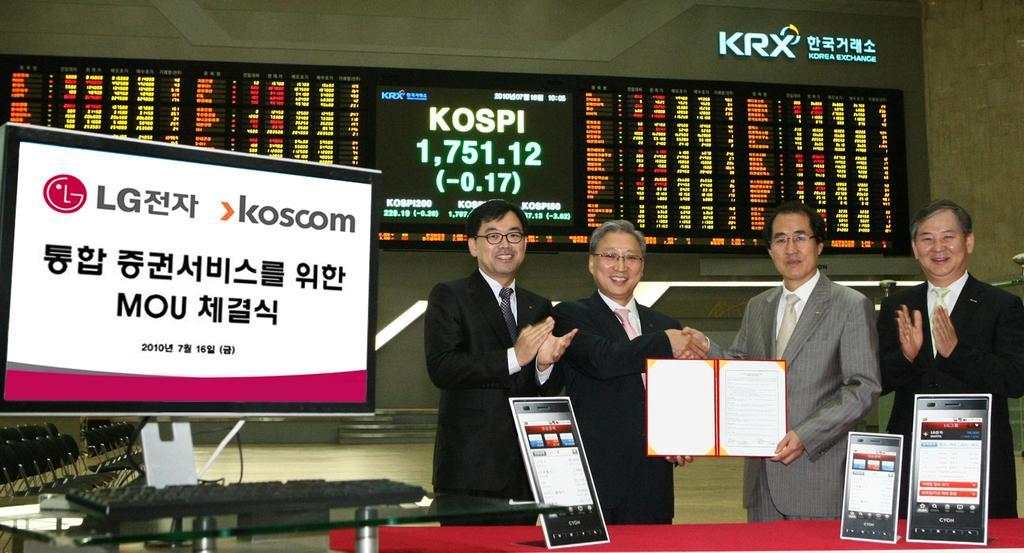Describe this image in one or two sentences. In this image there are persons standing, there is a person holding an object, there is table truncated towards the bottom of the image, there are objects on the table, there is a keyboard on the table, there is a monitor, there are objects truncated towards the left of the image, there are screens, there is text and numbers on the screen, there is wall truncated towards the right of the image, there is wall truncated towards the top of the image. 